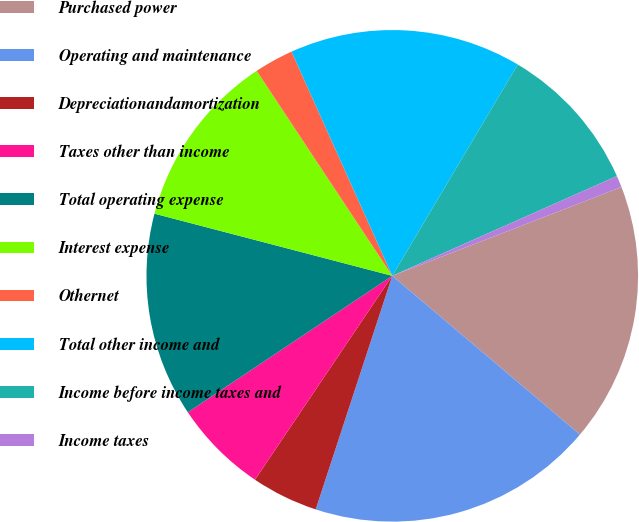<chart> <loc_0><loc_0><loc_500><loc_500><pie_chart><fcel>Purchased power<fcel>Operating and maintenance<fcel>Depreciationandamortization<fcel>Taxes other than income<fcel>Total operating expense<fcel>Interest expense<fcel>Othernet<fcel>Total other income and<fcel>Income before income taxes and<fcel>Income taxes<nl><fcel>17.06%<fcel>18.87%<fcel>4.39%<fcel>6.2%<fcel>13.44%<fcel>11.63%<fcel>2.58%<fcel>15.25%<fcel>9.82%<fcel>0.77%<nl></chart> 